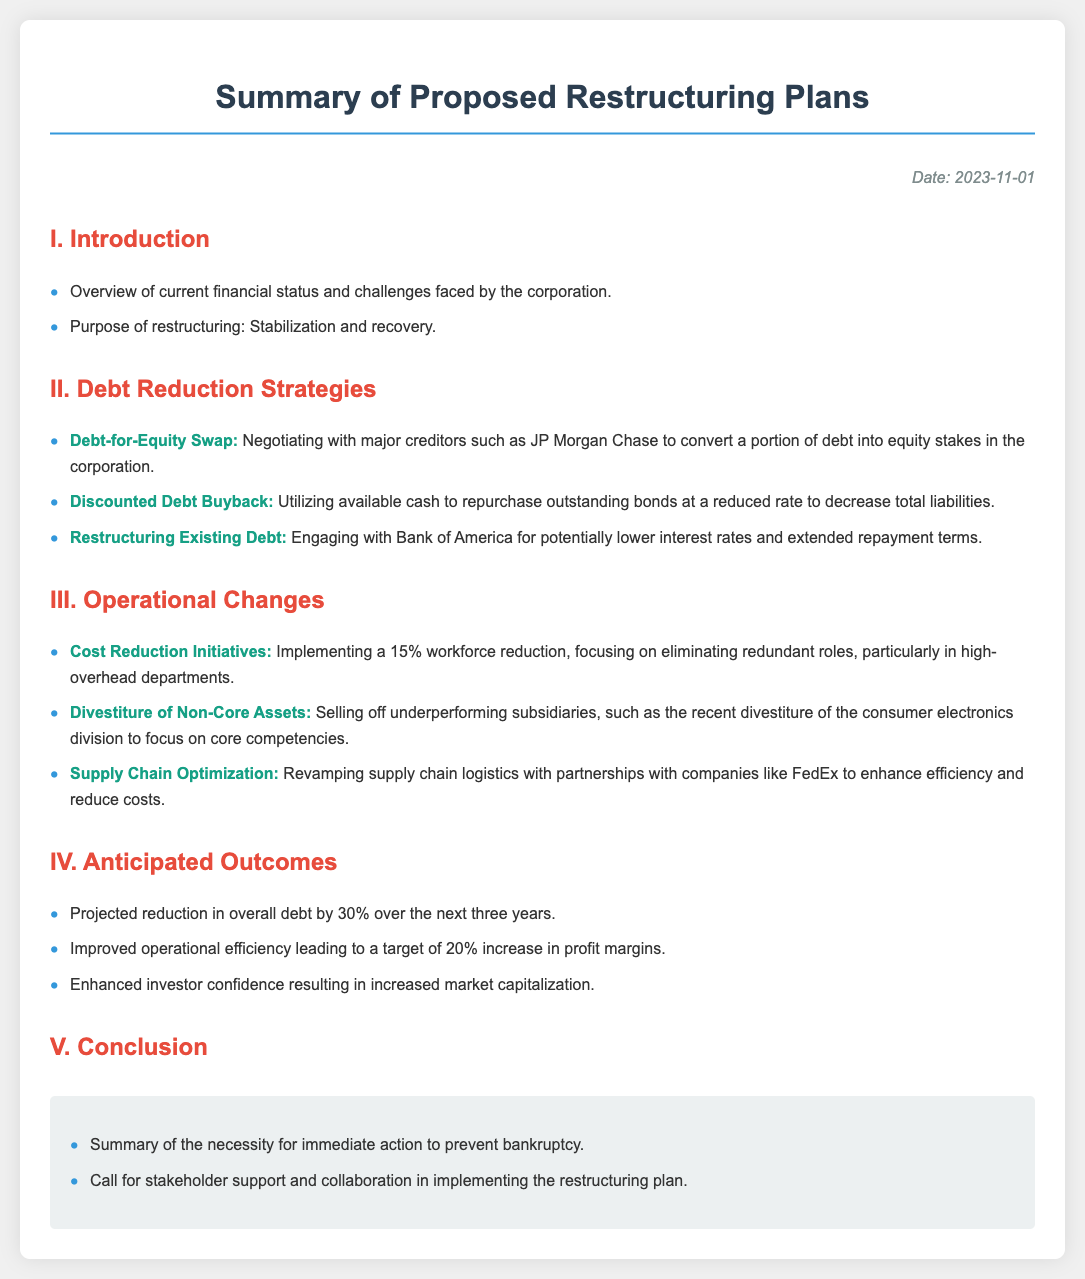What is the date of the document? The date of the document is stated in the top right corner under "Date".
Answer: 2023-11-01 Who is being negotiated with for the Debt-for-Equity Swap? The document mentions negotiating with major creditors specifically identified in the debt reduction strategies.
Answer: JP Morgan Chase What is the anticipated reduction in overall debt? This figure is found in the "Anticipated Outcomes" section, which summarizes the expected results from the restructuring plan.
Answer: 30% What type of cost reduction initiative involves workforce changes? The section on operational changes specifies initiatives aimed at reducing costs through organizational adjustments, including employment levels.
Answer: 15% workforce reduction Which division was recently divested to focus on core competencies? The operational changes section lists this as part of the strategy for divestiture of non-core assets.
Answer: consumer electronics division What is the expected increase in profit margins? This information can be found in the anticipated outcomes, specifying projected targets following the restructuring efforts.
Answer: 20% What is the primary purpose of the restructuring? The introduction section outlines the main goal for undertaking the restructuring measures.
Answer: Stabilization and recovery What is one method mentioned for lowering interest rates on existing debt? The strategies for debt reduction outline various approaches to improve financial obligations, indicating specific creditor engagement.
Answer: Bank of America 